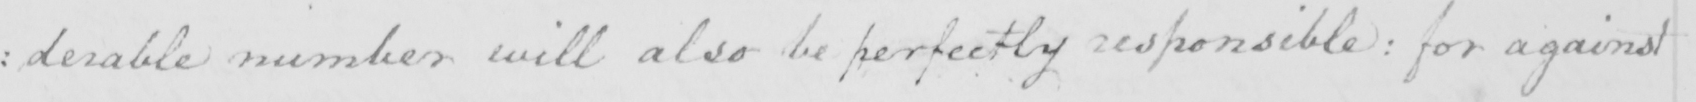Please provide the text content of this handwritten line. : derable number will also be perfectly responsible :  for against 